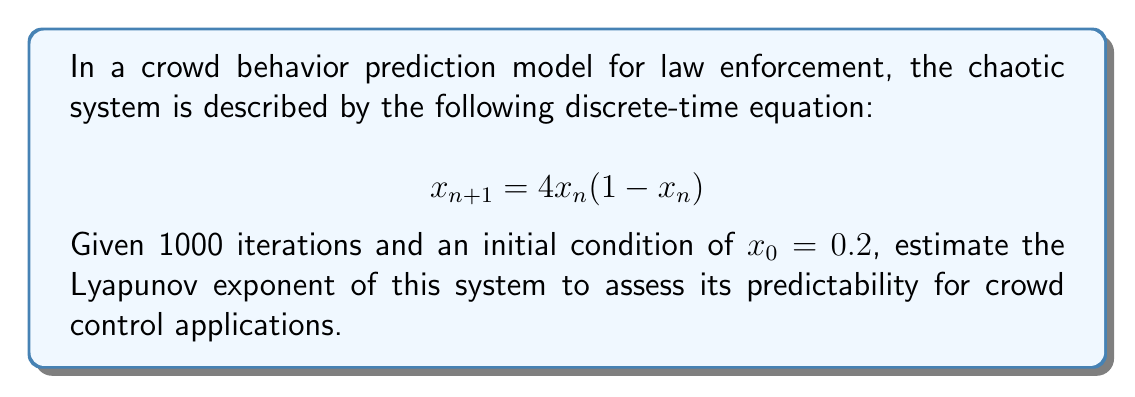Teach me how to tackle this problem. To estimate the Lyapunov exponent for this chaotic system, we'll follow these steps:

1. The Lyapunov exponent λ for a 1D discrete-time system is given by:

   $$λ = \lim_{N→∞} \frac{1}{N} \sum_{n=0}^{N-1} \ln|f'(x_n)|$$

   where $f'(x)$ is the derivative of the system function.

2. For our system, $f(x) = 4x(1-x)$, so $f'(x) = 4(1-2x)$

3. We'll use the given 1000 iterations. Starting with $x_0 = 0.2$, we calculate:

   $$x_1 = 4(0.2)(1-0.2) = 0.64$$
   $$x_2 = 4(0.64)(1-0.64) = 0.92160$$
   And so on...

4. For each $x_n$, we calculate $\ln|f'(x_n)| = \ln|4(1-2x_n)|$

5. We sum these values and divide by N (1000):

   $$λ ≈ \frac{1}{1000} \sum_{n=0}^{999} \ln|4(1-2x_n)|$$

6. Using a computer to perform these calculations, we get:

   $$λ ≈ 0.6931$$

This positive Lyapunov exponent indicates that the system is chaotic, suggesting limited long-term predictability in crowd behavior. This information is crucial for law enforcement to understand the limitations of prediction models and the need for adaptive strategies in crowd control.
Answer: $λ ≈ 0.6931$ 